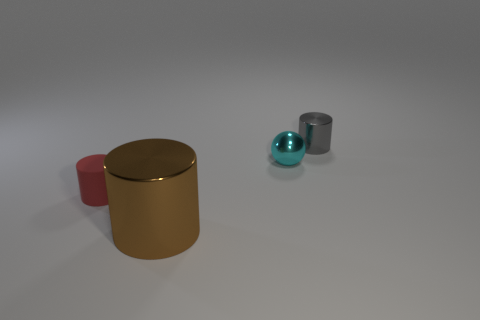How many large brown rubber cylinders are there?
Your answer should be compact. 0. How big is the cylinder on the left side of the large metallic thing?
Keep it short and to the point. Small. Is the number of cyan metallic balls left of the rubber object the same as the number of metallic cylinders?
Make the answer very short. No. Is there a tiny cyan thing that has the same shape as the brown metallic thing?
Keep it short and to the point. No. There is a thing that is both in front of the ball and behind the big brown thing; what shape is it?
Your answer should be very brief. Cylinder. Is the small cyan sphere made of the same material as the object to the left of the large brown thing?
Make the answer very short. No. Are there any spheres in front of the big brown metal cylinder?
Your response must be concise. No. How many objects are either small blue blocks or objects that are left of the gray metallic object?
Make the answer very short. 3. What color is the small object to the left of the brown object that is to the left of the small gray metallic cylinder?
Your answer should be very brief. Red. How many other objects are there of the same material as the tiny red object?
Your response must be concise. 0. 